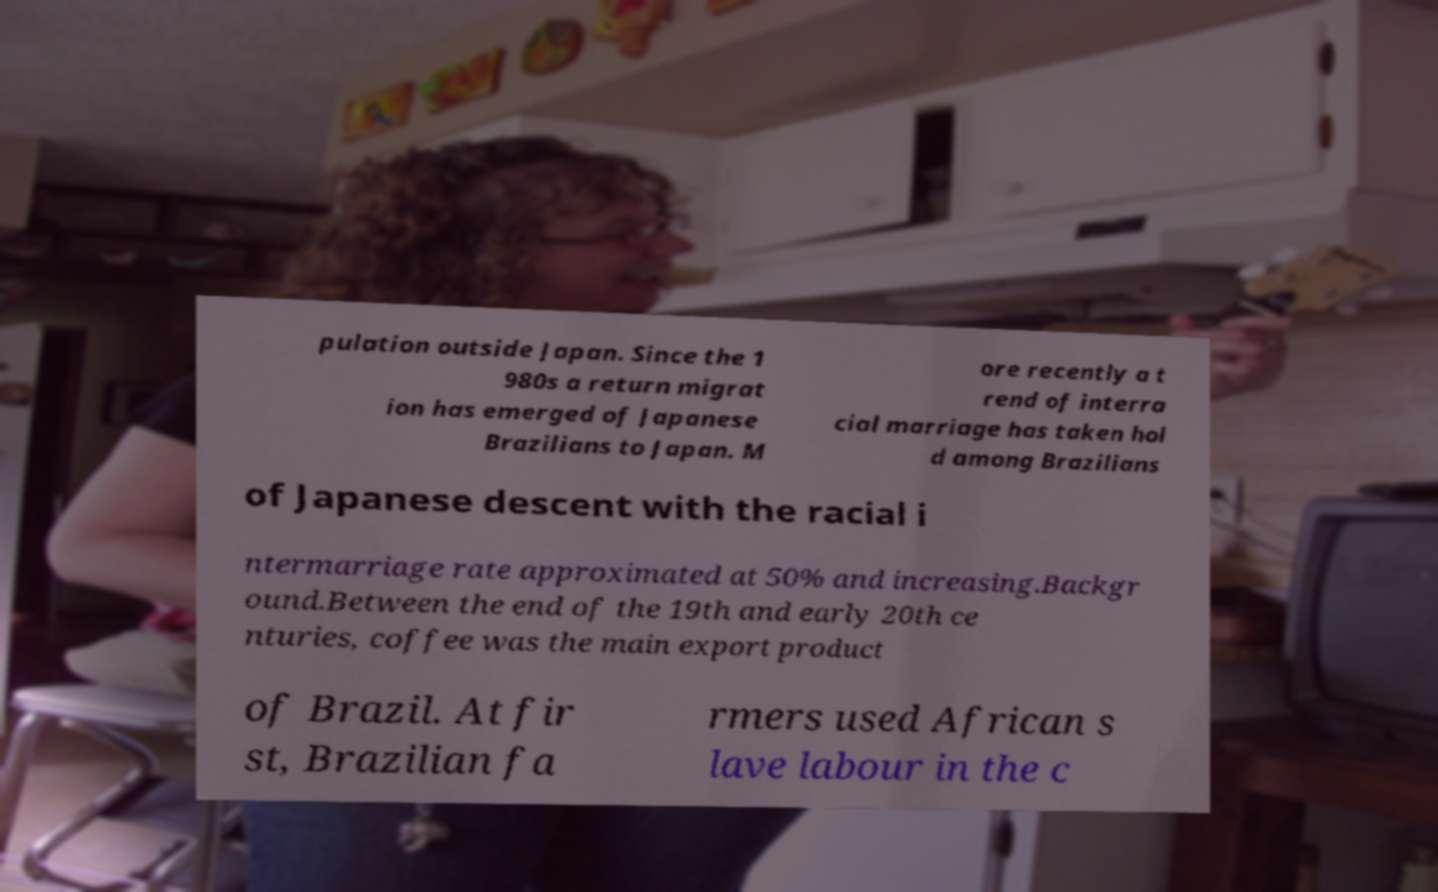What messages or text are displayed in this image? I need them in a readable, typed format. pulation outside Japan. Since the 1 980s a return migrat ion has emerged of Japanese Brazilians to Japan. M ore recently a t rend of interra cial marriage has taken hol d among Brazilians of Japanese descent with the racial i ntermarriage rate approximated at 50% and increasing.Backgr ound.Between the end of the 19th and early 20th ce nturies, coffee was the main export product of Brazil. At fir st, Brazilian fa rmers used African s lave labour in the c 